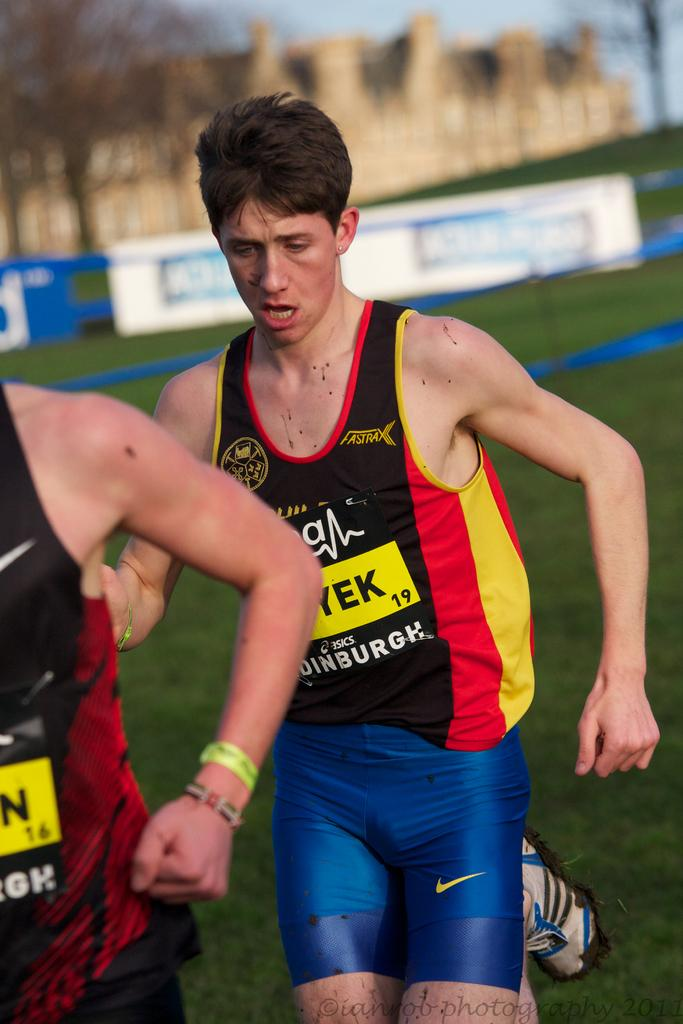<image>
Write a terse but informative summary of the picture. a boy running while wearing a jersey with FASTRAX label on it. 